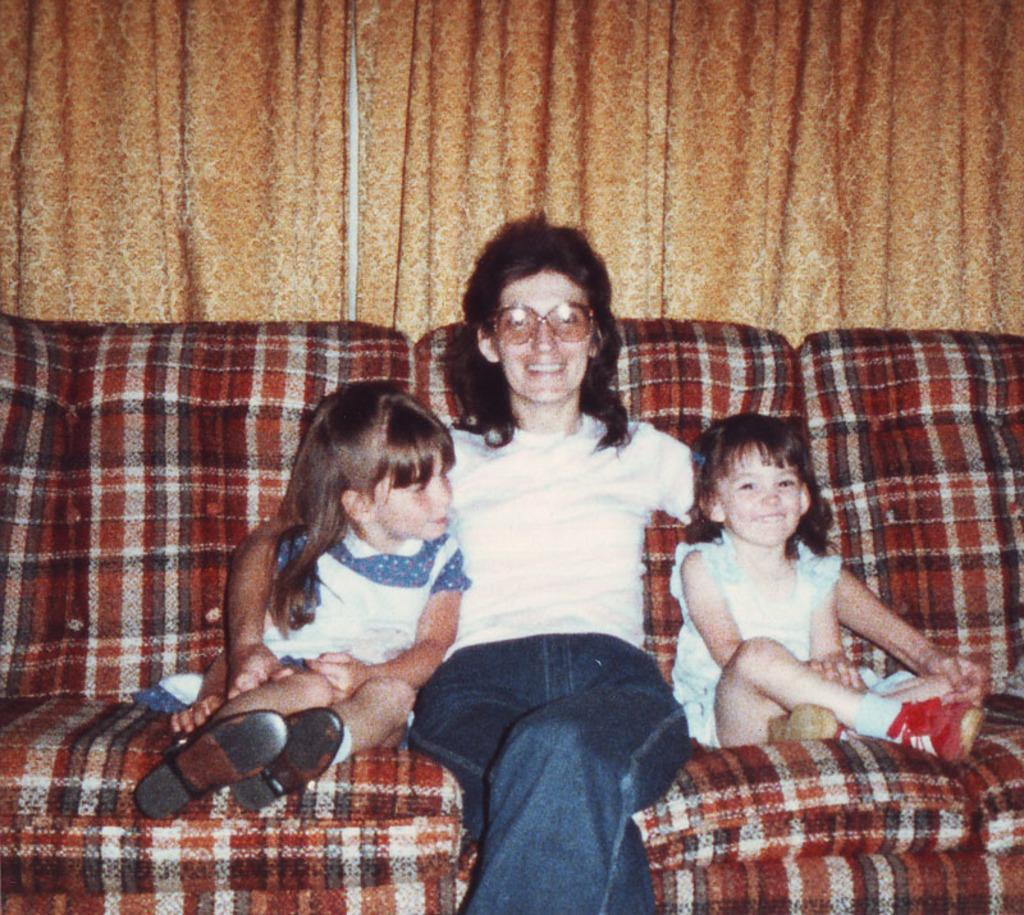Who is present in the image with the woman? There are two children in the image with the woman. What are the woman and children doing in the image? The woman and children are sitting on a couch. What can be seen in the background of the image? There is a curtain visible in the image. How is the woman feeling in the image? The woman is smiling in the image. What type of breakfast is being served on the swing in the image? There is no swing or breakfast present in the image. 